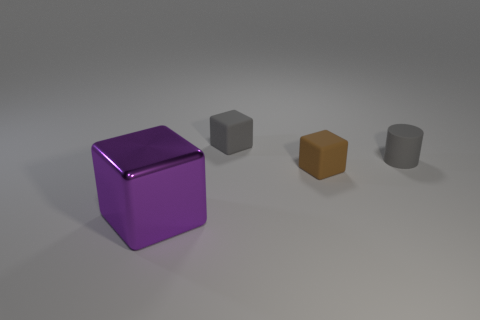Are there more brown objects than rubber blocks?
Provide a short and direct response. No. There is a large metal block; does it have the same color as the rubber cube behind the tiny cylinder?
Your answer should be compact. No. There is a cube that is left of the brown matte block and behind the large shiny object; what is its color?
Keep it short and to the point. Gray. How many other things are there of the same material as the large purple cube?
Your answer should be very brief. 0. Is the number of large purple metallic cylinders less than the number of brown cubes?
Your response must be concise. Yes. Does the large purple thing have the same material as the gray object to the left of the small brown rubber cube?
Offer a terse response. No. What shape is the matte thing behind the tiny rubber cylinder?
Make the answer very short. Cube. Is there any other thing of the same color as the large shiny thing?
Give a very brief answer. No. Are there fewer small matte cubes that are in front of the gray rubber cylinder than brown things?
Keep it short and to the point. No. What number of objects are the same size as the cylinder?
Ensure brevity in your answer.  2. 